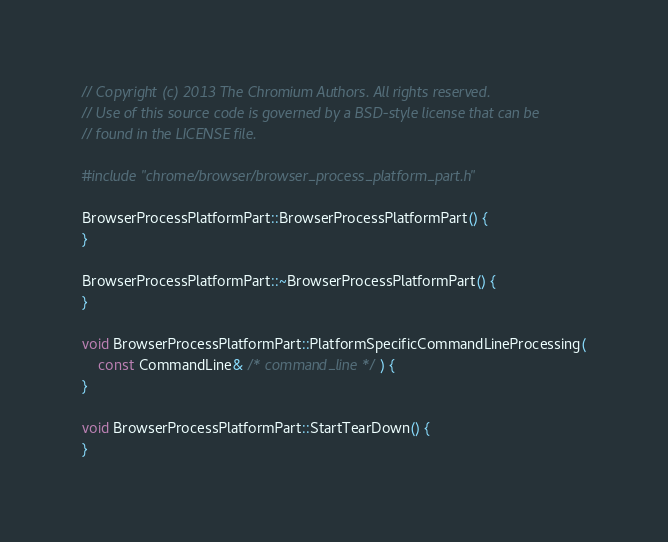Convert code to text. <code><loc_0><loc_0><loc_500><loc_500><_C++_>// Copyright (c) 2013 The Chromium Authors. All rights reserved.
// Use of this source code is governed by a BSD-style license that can be
// found in the LICENSE file.

#include "chrome/browser/browser_process_platform_part.h"

BrowserProcessPlatformPart::BrowserProcessPlatformPart() {
}

BrowserProcessPlatformPart::~BrowserProcessPlatformPart() {
}

void BrowserProcessPlatformPart::PlatformSpecificCommandLineProcessing(
    const CommandLine& /* command_line */) {
}

void BrowserProcessPlatformPart::StartTearDown() {
}
</code> 